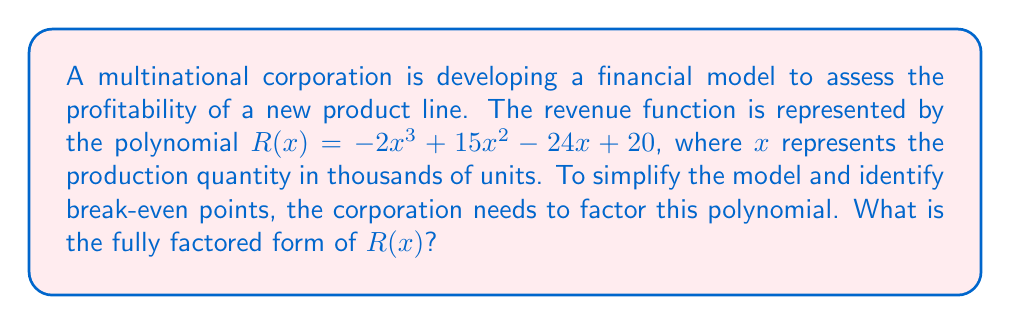Help me with this question. Let's approach this step-by-step:

1) First, we need to identify if there are any common factors. In this case, there are no common factors for all terms.

2) Next, we can try to factor by grouping. However, with four terms, this method isn't immediately applicable.

3) Let's consider the possibility that this might be a cubic function with a factor of $(x - a)$. We can use the rational root theorem to find potential roots.

4) The possible rational roots are the factors of the constant term (20): ±1, ±2, ±4, ±5, ±10, ±20

5) Testing these values, we find that $R(2) = 0$. So $(x - 2)$ is a factor.

6) We can use polynomial long division to divide $R(x)$ by $(x - 2)$:

   $$-2x^3 + 15x^2 - 24x + 20 = (x - 2)(-2x^2 + 11x - 10)$$

7) Now we need to factor the quadratic $-2x^2 + 11x - 10$

8) We can factor this as: $-(2x^2 - 11x + 5)$

9) The quadratic formula reveals that this factors to: $-(2x - 1)(x - 5)$

10) Therefore, our final factored form is:

    $$R(x) = -2(x - 2)(x - 5)(x - \frac{1}{2})$$

This factored form allows the corporation to easily identify the break-even points (roots) of the revenue function, which occur at production quantities of 0.5, 2, and 5 thousand units.
Answer: $R(x) = -2(x - 2)(x - 5)(x - \frac{1}{2})$ 